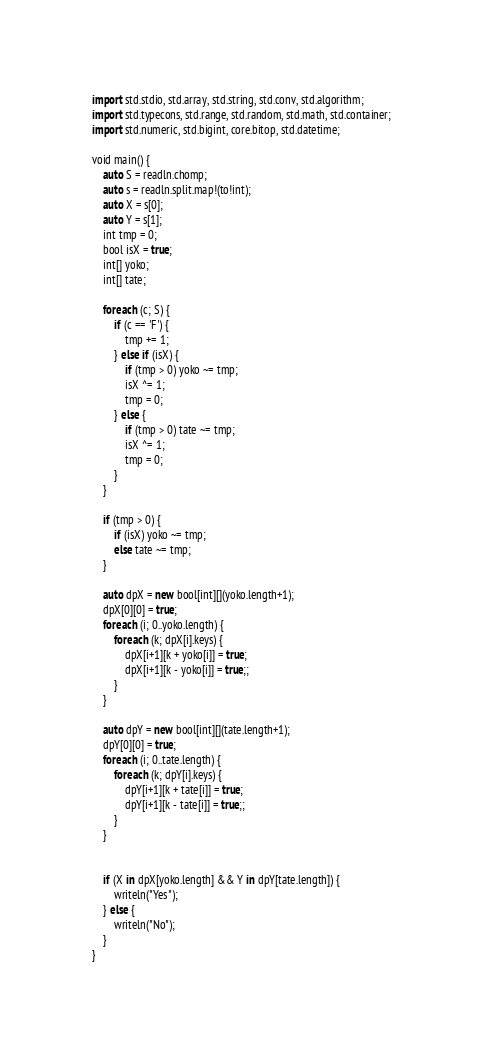<code> <loc_0><loc_0><loc_500><loc_500><_D_>import std.stdio, std.array, std.string, std.conv, std.algorithm;
import std.typecons, std.range, std.random, std.math, std.container;
import std.numeric, std.bigint, core.bitop, std.datetime;

void main() {
    auto S = readln.chomp;
    auto s = readln.split.map!(to!int);
    auto X = s[0];
    auto Y = s[1];
    int tmp = 0;
    bool isX = true;
    int[] yoko;
    int[] tate;

    foreach (c; S) {
        if (c == 'F') {
            tmp += 1;
        } else if (isX) {
            if (tmp > 0) yoko ~= tmp;
            isX ^= 1;
            tmp = 0;
        } else {
            if (tmp > 0) tate ~= tmp;
            isX ^= 1;
            tmp = 0;
        }
    }

    if (tmp > 0) {
        if (isX) yoko ~= tmp;
        else tate ~= tmp;
    }

    auto dpX = new bool[int][](yoko.length+1);
    dpX[0][0] = true;
    foreach (i; 0..yoko.length) {
        foreach (k; dpX[i].keys) {
            dpX[i+1][k + yoko[i]] = true;
            dpX[i+1][k - yoko[i]] = true;;
        }
    }

    auto dpY = new bool[int][](tate.length+1);
    dpY[0][0] = true;
    foreach (i; 0..tate.length) {
        foreach (k; dpY[i].keys) {
            dpY[i+1][k + tate[i]] = true;
            dpY[i+1][k - tate[i]] = true;;
        }
    }


    if (X in dpX[yoko.length] && Y in dpY[tate.length]) {
        writeln("Yes");
    } else {
        writeln("No");
    }
}
</code> 